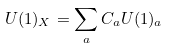Convert formula to latex. <formula><loc_0><loc_0><loc_500><loc_500>U ( 1 ) _ { X } = \sum _ { a } C _ { a } U ( 1 ) _ { a }</formula> 